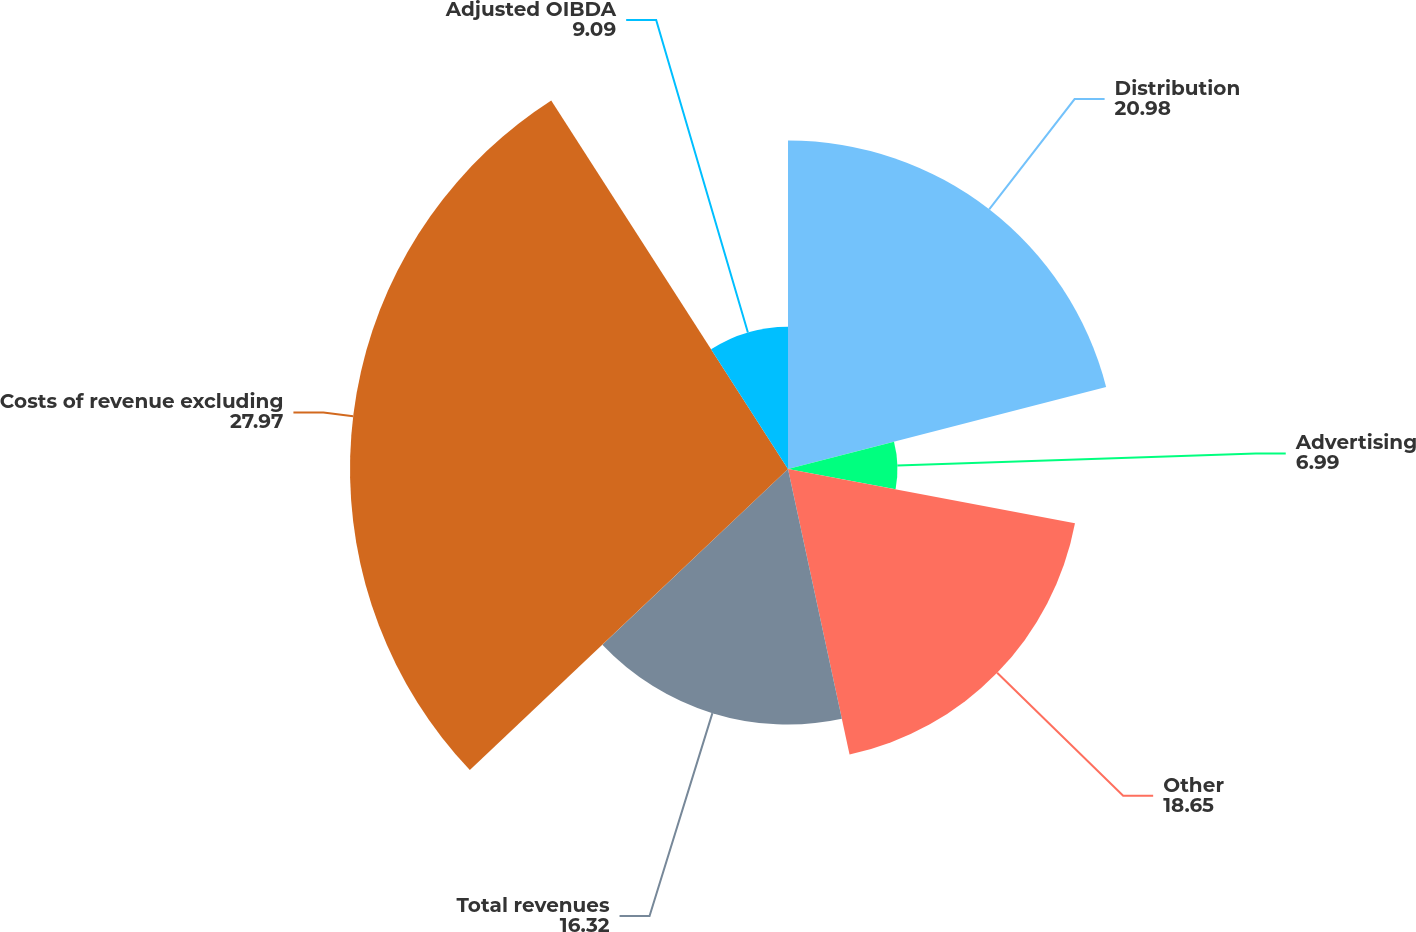Convert chart to OTSL. <chart><loc_0><loc_0><loc_500><loc_500><pie_chart><fcel>Distribution<fcel>Advertising<fcel>Other<fcel>Total revenues<fcel>Costs of revenue excluding<fcel>Adjusted OIBDA<nl><fcel>20.98%<fcel>6.99%<fcel>18.65%<fcel>16.32%<fcel>27.97%<fcel>9.09%<nl></chart> 